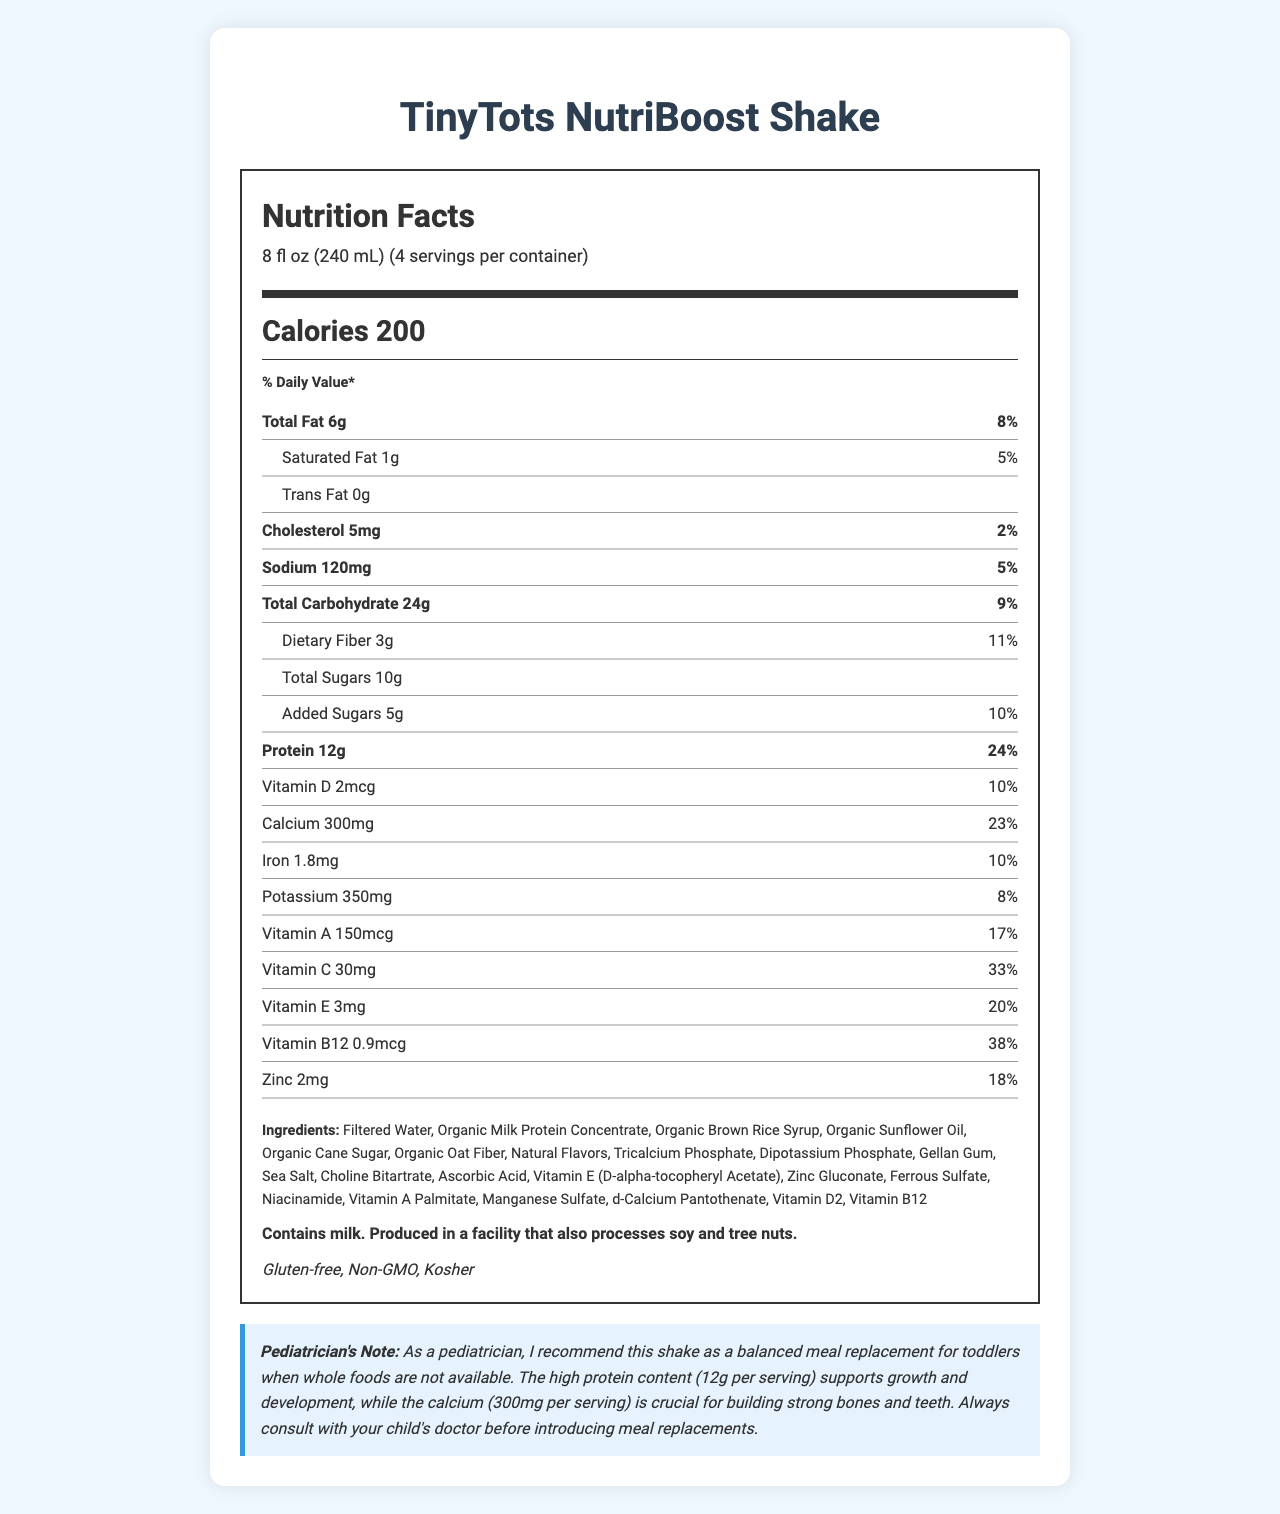what is the serving size? The serving size is explicitly mentioned under the serving information header.
Answer: 8 fl oz (240 mL) how many calories are in one serving? The calories per serving are clearly listed in the calorie info section.
Answer: 200 what percentage of the daily value of calcium does one serving provide? The calcium daily value percentage is provided in the nutrient row for calcium.
Answer: 23% how much protein is in one serving? The amount of protein per serving is listed in the nutrient row for protein.
Answer: 12g how many grams of dietary fiber are in this shake? The dietary fiber amount is shown in the sub-nutrient row for dietary fiber.
Answer: 3g which vitamins are listed in the nutrition facts? A. Vitamin D, Calcium, Vitamin E B. Vitamin C, Iron, Vitamin B12 C. Vitamin A, Vitamin C, Zinc D. All of the above The document lists Vitamin D, Vitamin E, Vitamin C, Vitamin A, Vitamin B12, and zinc as present.
Answer: D what is the daily value percentage for sodium? A. 5% B. 8% C. 10% D. 15% The daily value percentage for sodium is listed as 5% in the nutrient row for sodium.
Answer: A is this shake suitable for someone with a gluten allergy? Yes/No The dietary considerations section lists "Gluten-free".
Answer: Yes summarize the main benefits of this toddler meal replacement shake as per the document. The document indicates that the shake offers important nutrients for toddlers, meets dietary considerations, and has related warnings.
Answer: The TinyTots NutriBoost Shake provides a balanced meal replacement for toddlers, offering high protein (12g per serving) for growth and calcium (300mg per serving) for strong bones and teeth. It is gluten-free, non-GMO, and kosher, but contains milk and may be produced in a facility that processes soy and tree nuts. Always consult with a child's doctor before use. what is the main ingredient in the shake? The first ingredient listed is filtered water.
Answer: Filtered Water which allergens are mentioned on the label? The allergen info section specifies that the product contains milk and may be processed in a facility that handles soy and tree nuts.
Answer: Milk, Soy, Tree nuts does the shake contain any trans fat? The trans fat content is listed as 0g in the sub-nutrient row for trans fat.
Answer: No how many servings are there per container? The container serving info specifies 4 servings per container.
Answer: 4 can we determine if the ingredients are organic? Many ingredients are marked as organic, confirming they are organic.
Answer: Yes what is the production date of the shake? The document does not provide any information about the production date of the shake.
Answer: Not enough information 